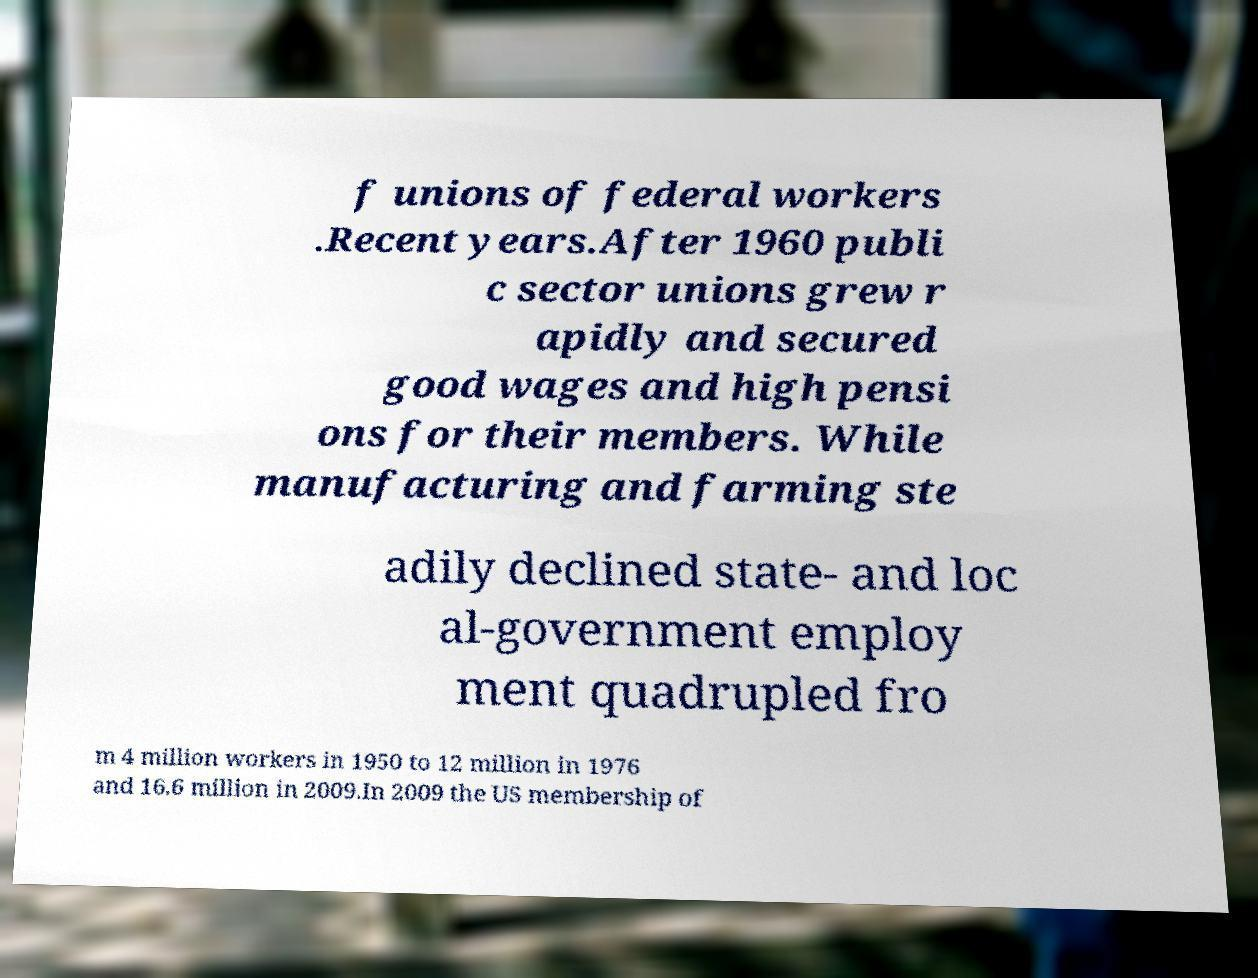What messages or text are displayed in this image? I need them in a readable, typed format. f unions of federal workers .Recent years.After 1960 publi c sector unions grew r apidly and secured good wages and high pensi ons for their members. While manufacturing and farming ste adily declined state- and loc al-government employ ment quadrupled fro m 4 million workers in 1950 to 12 million in 1976 and 16.6 million in 2009.In 2009 the US membership of 